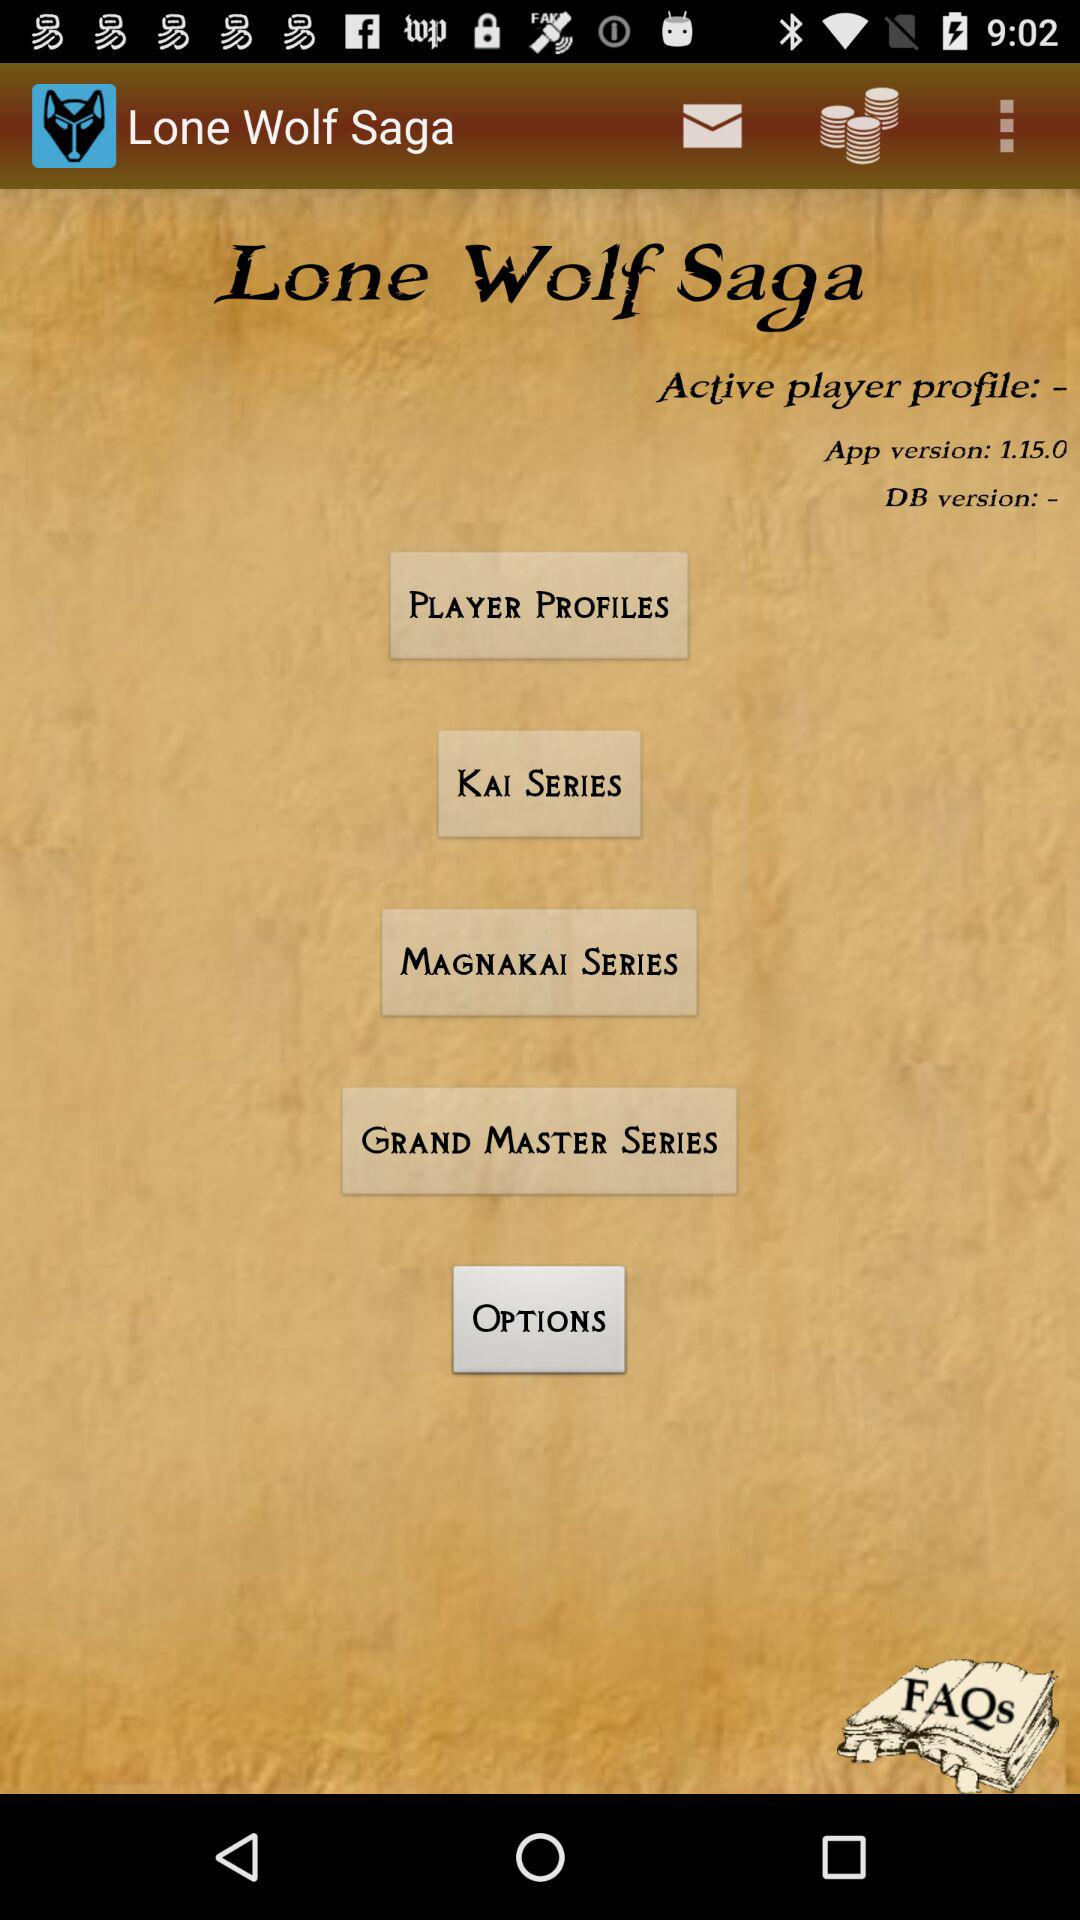What is the version? The version is 1.15.0. 